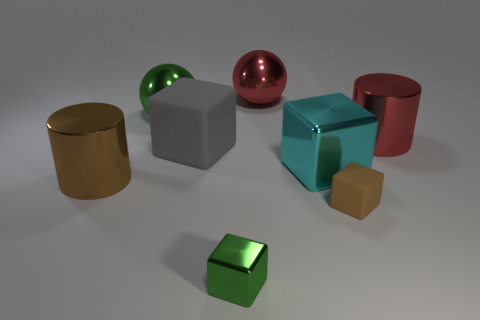Subtract all tiny matte blocks. How many blocks are left? 3 Subtract all brown blocks. How many blocks are left? 3 Subtract all balls. How many objects are left? 6 Subtract 1 spheres. How many spheres are left? 1 Add 1 spheres. How many objects exist? 9 Add 1 large purple matte cylinders. How many large purple matte cylinders exist? 1 Subtract 0 cyan balls. How many objects are left? 8 Subtract all red balls. Subtract all green blocks. How many balls are left? 1 Subtract all red spheres. How many brown cubes are left? 1 Subtract all yellow things. Subtract all big gray objects. How many objects are left? 7 